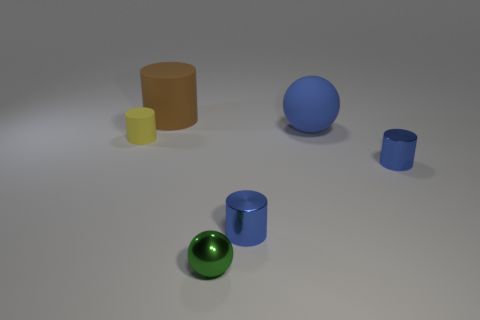Subtract all yellow cylinders. How many cylinders are left? 3 Subtract all brown cylinders. How many cylinders are left? 3 Subtract 2 cylinders. How many cylinders are left? 2 Subtract all green cylinders. Subtract all green blocks. How many cylinders are left? 4 Add 2 tiny green spheres. How many objects exist? 8 Subtract all cylinders. How many objects are left? 2 Add 2 green shiny balls. How many green shiny balls are left? 3 Add 4 metallic balls. How many metallic balls exist? 5 Subtract 0 red balls. How many objects are left? 6 Subtract all blue cylinders. Subtract all blue matte spheres. How many objects are left? 3 